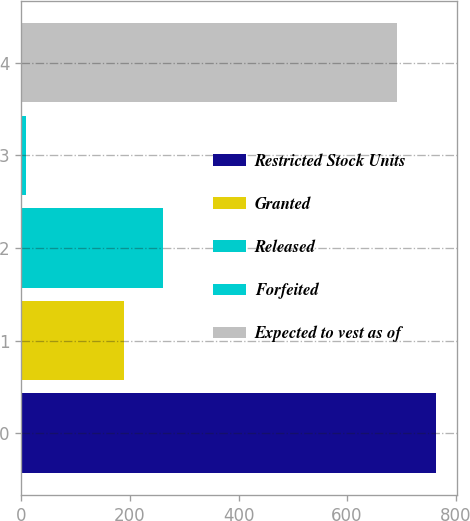Convert chart. <chart><loc_0><loc_0><loc_500><loc_500><bar_chart><fcel>Restricted Stock Units<fcel>Granted<fcel>Released<fcel>Forfeited<fcel>Expected to vest as of<nl><fcel>763.5<fcel>189<fcel>261.5<fcel>8<fcel>691<nl></chart> 